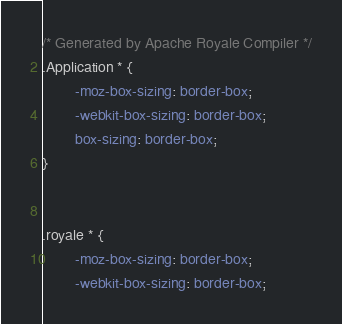<code> <loc_0><loc_0><loc_500><loc_500><_CSS_>/* Generated by Apache Royale Compiler */
.Application * {
        -moz-box-sizing: border-box;
        -webkit-box-sizing: border-box;
        box-sizing: border-box;
}


.royale * {
        -moz-box-sizing: border-box;
        -webkit-box-sizing: border-box;</code> 